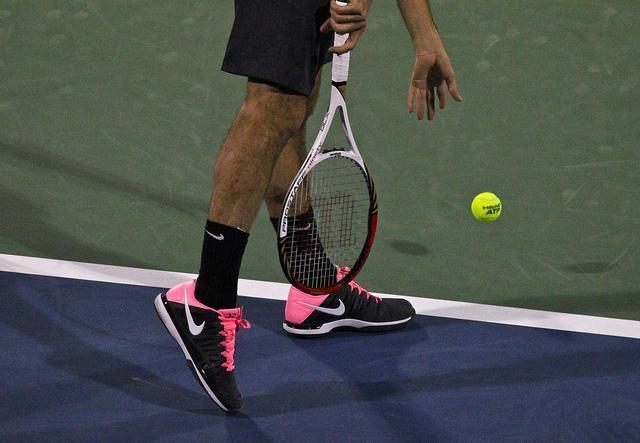How many people can you see?
Give a very brief answer. 1. 